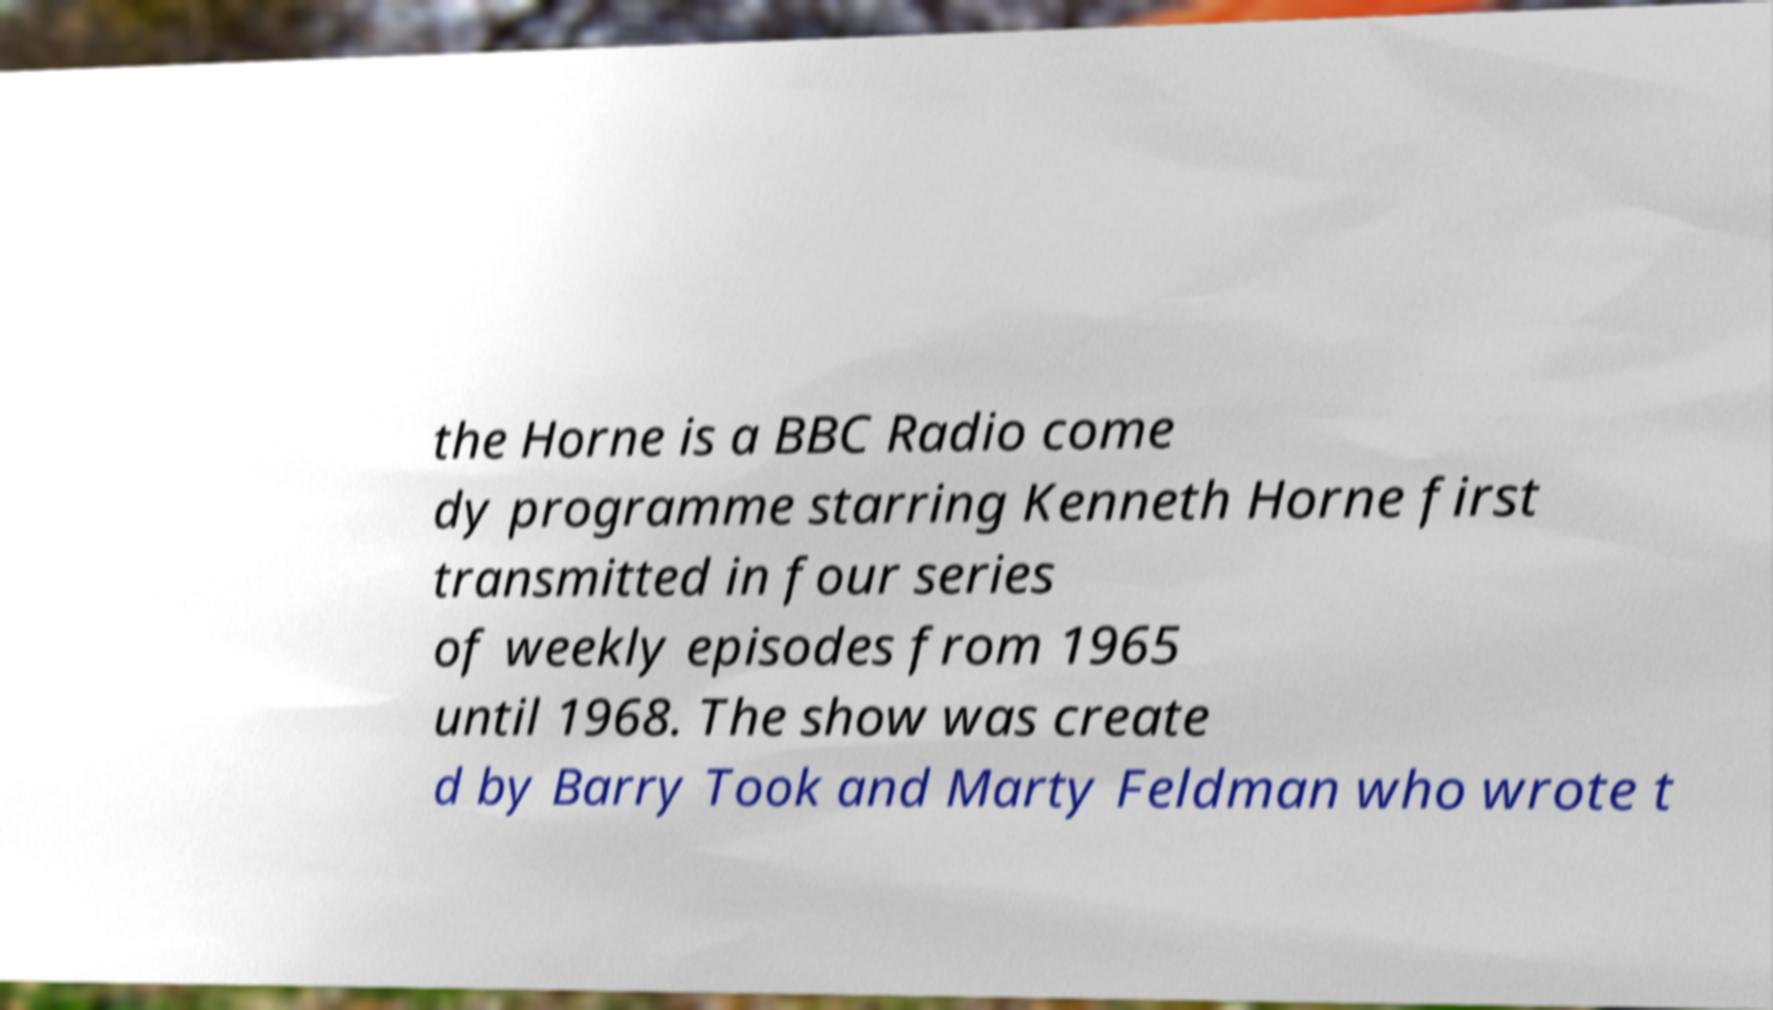Can you accurately transcribe the text from the provided image for me? the Horne is a BBC Radio come dy programme starring Kenneth Horne first transmitted in four series of weekly episodes from 1965 until 1968. The show was create d by Barry Took and Marty Feldman who wrote t 